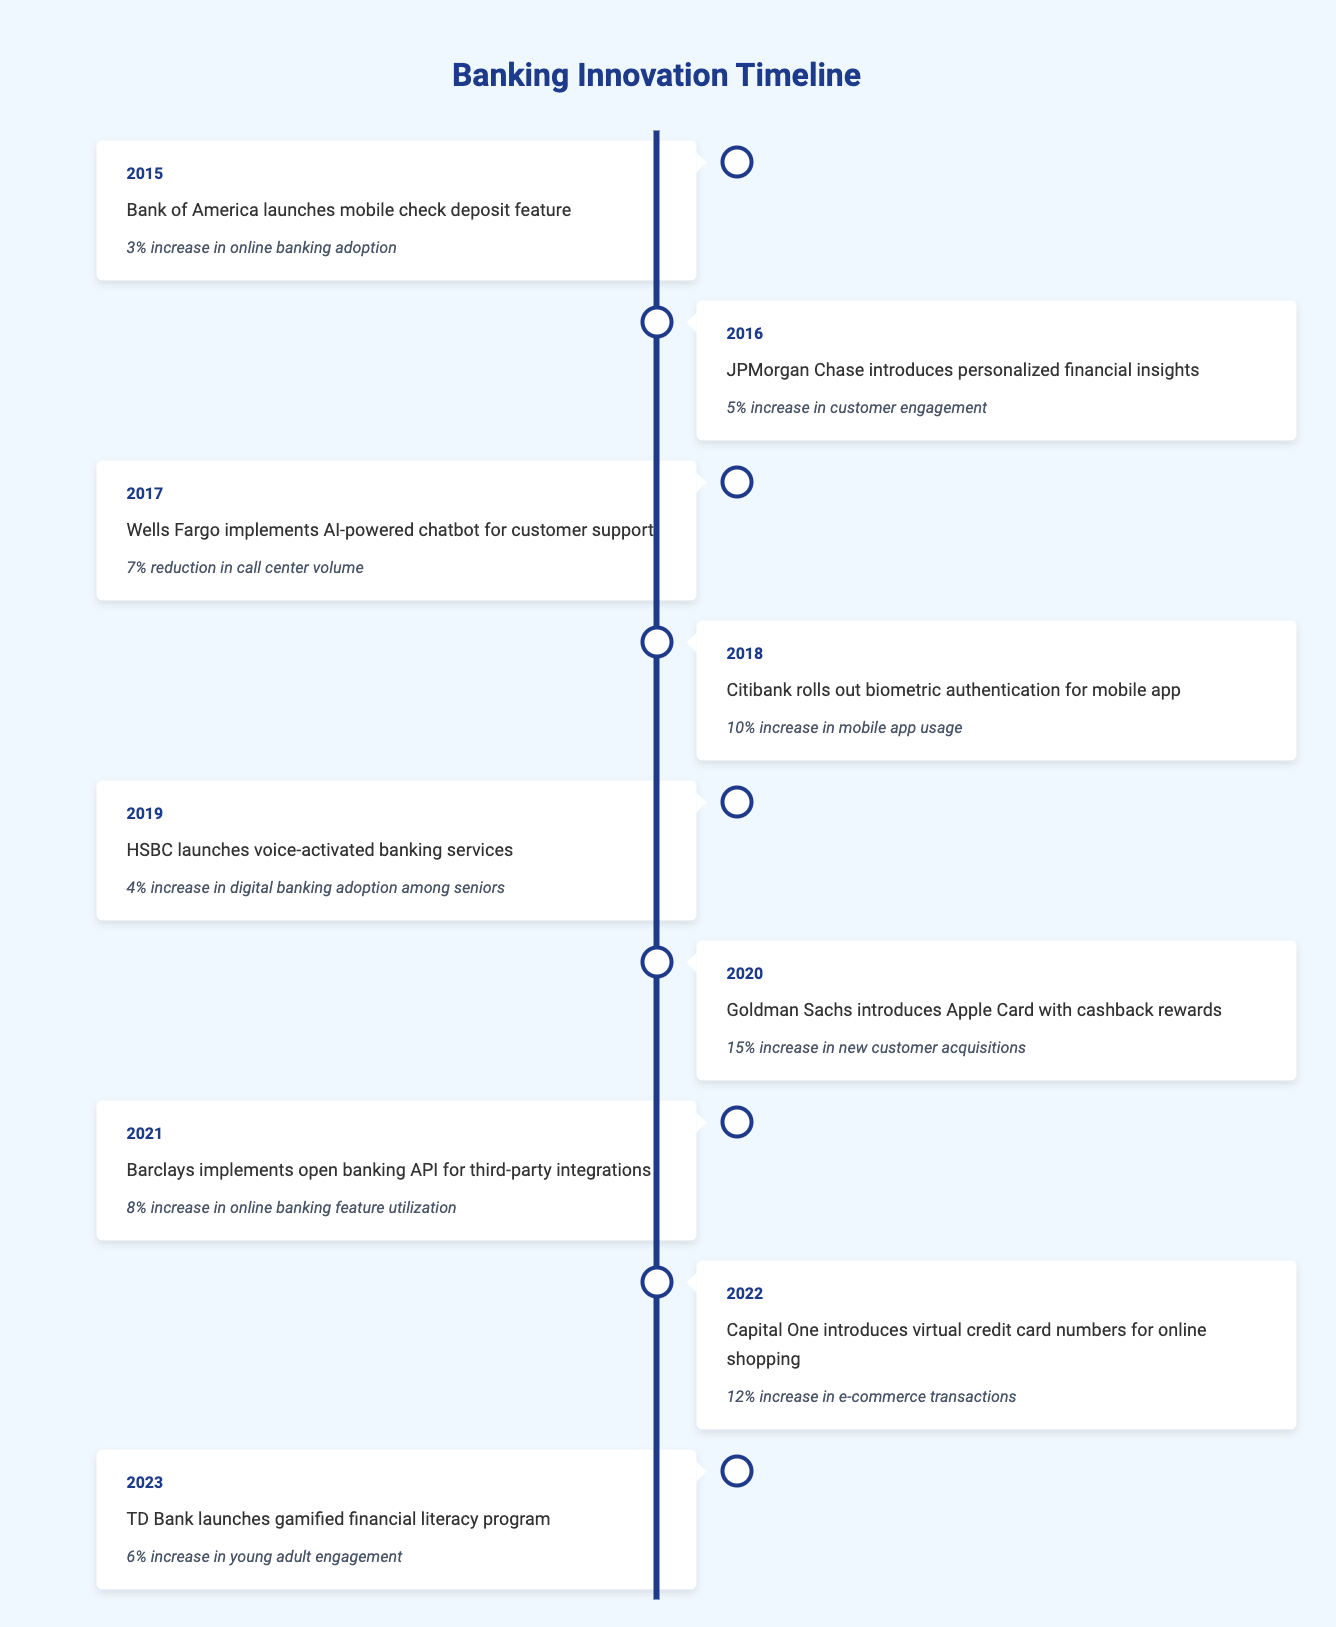What was the impact of the mobile check deposit feature launched by Bank of America in 2015? According to the table, the mobile check deposit feature introduced by Bank of America led to a 3% increase in online banking adoption.
Answer: 3% increase in online banking adoption Which event in 2020 had the most significant impact on customer acquisitions? The table indicates that in 2020, Goldman Sachs introduced the Apple Card with cashback rewards, which resulted in a 15% increase in new customer acquisitions, the highest impact recorded.
Answer: 15% increase in new customer acquisitions Was there an increase in digital banking adoption among seniors in 2019 and if so, by what percentage? The 2019 entry specifies that HSBC launched voice-activated banking services, leading to a 4% increase in digital banking adoption among seniors.
Answer: Yes, 4% increase What is the average percentage increase in customer engagement recorded from 2016 to 2022? The increases from 2016 to 2022 are: 5%, 10%, 12%, and 6%. Summing these values gives 33%, and dividing by 4 (the number of events) yields an average of 8.25%.
Answer: 8.25% Which year saw the implementation of AI-powered chatbot services, and how did it affect call center volume? In 2017, Wells Fargo implemented AI-powered chatbot services, resulting in a 7% reduction in call center volume, according to the table.
Answer: 2017, 7% reduction in call center volume Did any event have a negative impact indicated in the table? The table only reflects positive impacts or increases in engagement or adoption, and does not mention any negative impacts.
Answer: No What was the total percentage increase in online banking feature utilization from 2015 to 2021? The increases from 2015 (3%) and 2021 (8%) total to 11%. This is calculated by summing the impact percentages from both years: 3% + 8% = 11%.
Answer: 11% 